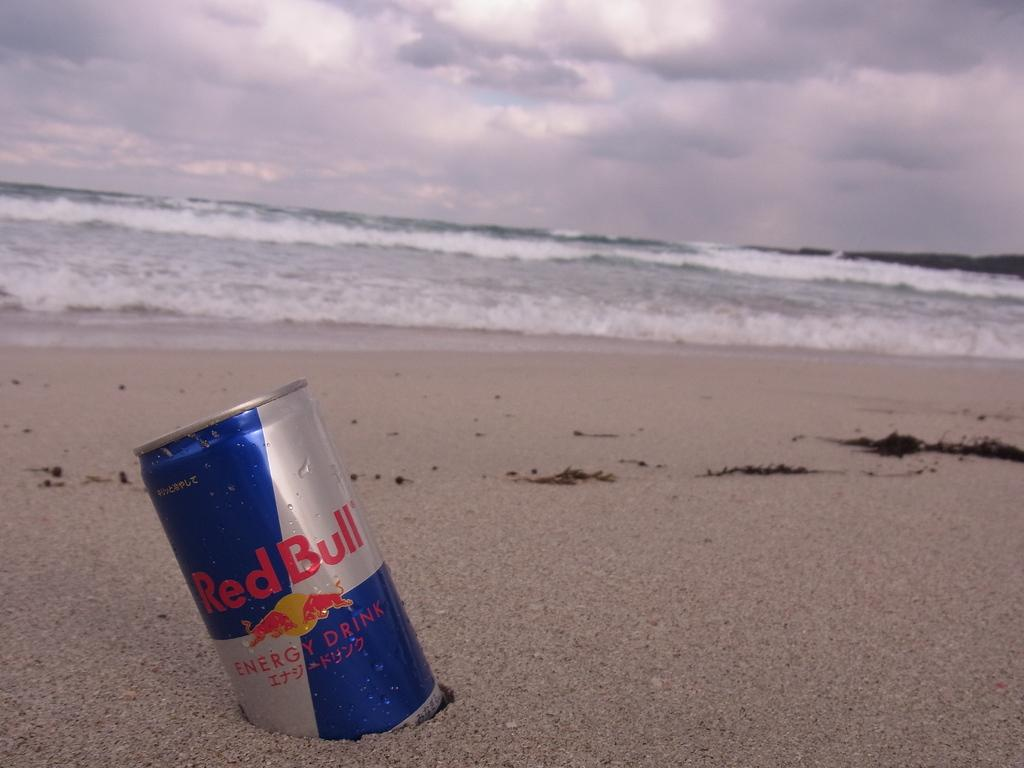<image>
Provide a brief description of the given image. A can of Red Bull energy drink is sitting in the sand on a stormy beach 